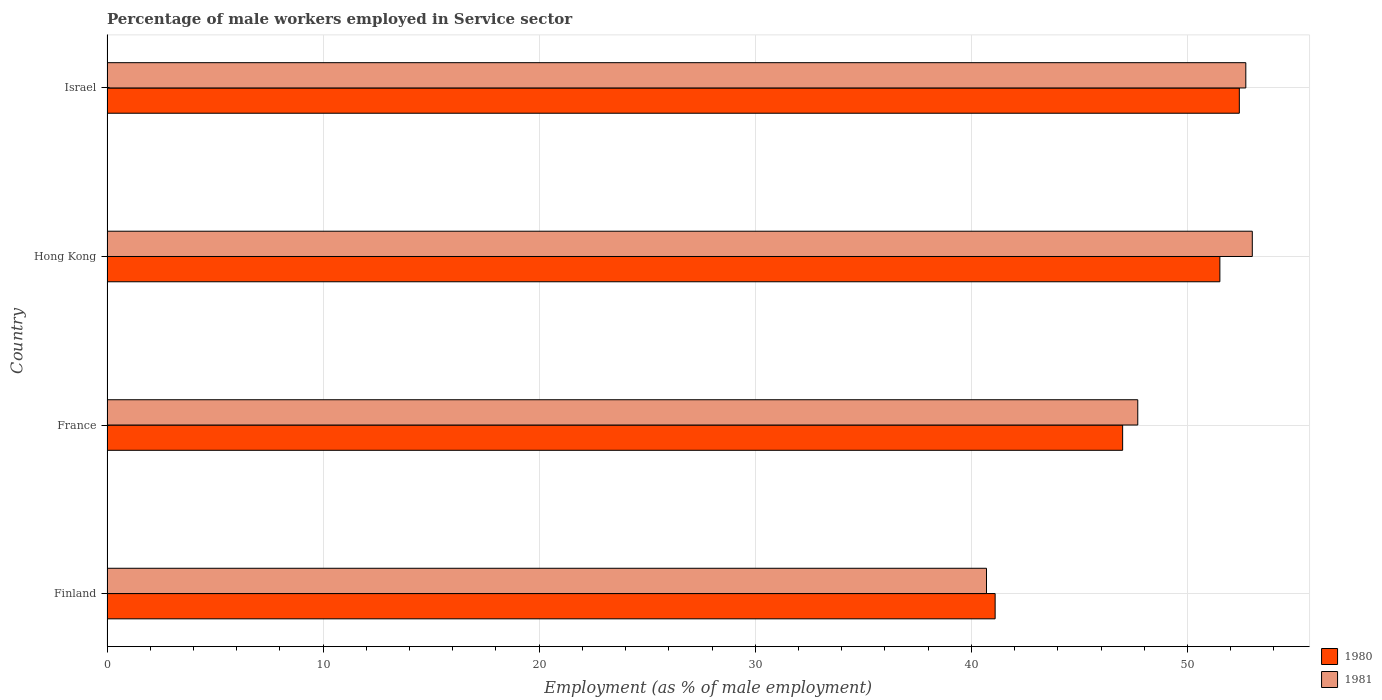How many different coloured bars are there?
Give a very brief answer. 2. How many groups of bars are there?
Provide a succinct answer. 4. Are the number of bars per tick equal to the number of legend labels?
Give a very brief answer. Yes. How many bars are there on the 1st tick from the top?
Provide a succinct answer. 2. How many bars are there on the 4th tick from the bottom?
Make the answer very short. 2. What is the label of the 3rd group of bars from the top?
Offer a very short reply. France. In how many cases, is the number of bars for a given country not equal to the number of legend labels?
Provide a succinct answer. 0. Across all countries, what is the maximum percentage of male workers employed in Service sector in 1981?
Your answer should be compact. 53. Across all countries, what is the minimum percentage of male workers employed in Service sector in 1980?
Your answer should be very brief. 41.1. In which country was the percentage of male workers employed in Service sector in 1981 maximum?
Keep it short and to the point. Hong Kong. What is the total percentage of male workers employed in Service sector in 1981 in the graph?
Keep it short and to the point. 194.1. What is the difference between the percentage of male workers employed in Service sector in 1980 in Finland and that in France?
Offer a very short reply. -5.9. What is the difference between the percentage of male workers employed in Service sector in 1980 in Hong Kong and the percentage of male workers employed in Service sector in 1981 in Israel?
Make the answer very short. -1.2. What is the average percentage of male workers employed in Service sector in 1981 per country?
Make the answer very short. 48.53. In how many countries, is the percentage of male workers employed in Service sector in 1981 greater than 46 %?
Your answer should be compact. 3. What is the ratio of the percentage of male workers employed in Service sector in 1981 in Finland to that in France?
Make the answer very short. 0.85. Is the difference between the percentage of male workers employed in Service sector in 1981 in France and Israel greater than the difference between the percentage of male workers employed in Service sector in 1980 in France and Israel?
Provide a succinct answer. Yes. What is the difference between the highest and the second highest percentage of male workers employed in Service sector in 1981?
Your answer should be compact. 0.3. What is the difference between the highest and the lowest percentage of male workers employed in Service sector in 1980?
Provide a succinct answer. 11.3. In how many countries, is the percentage of male workers employed in Service sector in 1980 greater than the average percentage of male workers employed in Service sector in 1980 taken over all countries?
Provide a short and direct response. 2. What does the 2nd bar from the top in Hong Kong represents?
Your answer should be very brief. 1980. How many countries are there in the graph?
Provide a succinct answer. 4. Does the graph contain any zero values?
Ensure brevity in your answer.  No. Does the graph contain grids?
Provide a short and direct response. Yes. What is the title of the graph?
Give a very brief answer. Percentage of male workers employed in Service sector. Does "1964" appear as one of the legend labels in the graph?
Offer a terse response. No. What is the label or title of the X-axis?
Provide a succinct answer. Employment (as % of male employment). What is the label or title of the Y-axis?
Your answer should be very brief. Country. What is the Employment (as % of male employment) of 1980 in Finland?
Provide a succinct answer. 41.1. What is the Employment (as % of male employment) of 1981 in Finland?
Keep it short and to the point. 40.7. What is the Employment (as % of male employment) in 1981 in France?
Your answer should be very brief. 47.7. What is the Employment (as % of male employment) in 1980 in Hong Kong?
Your response must be concise. 51.5. What is the Employment (as % of male employment) of 1981 in Hong Kong?
Your answer should be very brief. 53. What is the Employment (as % of male employment) of 1980 in Israel?
Offer a very short reply. 52.4. What is the Employment (as % of male employment) in 1981 in Israel?
Ensure brevity in your answer.  52.7. Across all countries, what is the maximum Employment (as % of male employment) in 1980?
Your response must be concise. 52.4. Across all countries, what is the maximum Employment (as % of male employment) in 1981?
Make the answer very short. 53. Across all countries, what is the minimum Employment (as % of male employment) in 1980?
Your response must be concise. 41.1. Across all countries, what is the minimum Employment (as % of male employment) of 1981?
Your answer should be compact. 40.7. What is the total Employment (as % of male employment) of 1980 in the graph?
Provide a succinct answer. 192. What is the total Employment (as % of male employment) in 1981 in the graph?
Offer a terse response. 194.1. What is the difference between the Employment (as % of male employment) of 1980 in Finland and that in France?
Your response must be concise. -5.9. What is the difference between the Employment (as % of male employment) of 1981 in Finland and that in France?
Your response must be concise. -7. What is the difference between the Employment (as % of male employment) in 1980 in Finland and that in Hong Kong?
Your response must be concise. -10.4. What is the difference between the Employment (as % of male employment) of 1981 in Finland and that in Hong Kong?
Offer a terse response. -12.3. What is the difference between the Employment (as % of male employment) of 1980 in Finland and that in Israel?
Your answer should be very brief. -11.3. What is the difference between the Employment (as % of male employment) of 1981 in Finland and that in Israel?
Your response must be concise. -12. What is the difference between the Employment (as % of male employment) of 1980 in France and that in Hong Kong?
Keep it short and to the point. -4.5. What is the difference between the Employment (as % of male employment) in 1981 in France and that in Hong Kong?
Provide a short and direct response. -5.3. What is the difference between the Employment (as % of male employment) of 1980 in France and that in Israel?
Your answer should be compact. -5.4. What is the difference between the Employment (as % of male employment) of 1980 in Finland and the Employment (as % of male employment) of 1981 in France?
Ensure brevity in your answer.  -6.6. What is the difference between the Employment (as % of male employment) of 1980 in Finland and the Employment (as % of male employment) of 1981 in Israel?
Provide a short and direct response. -11.6. What is the difference between the Employment (as % of male employment) of 1980 in France and the Employment (as % of male employment) of 1981 in Hong Kong?
Provide a short and direct response. -6. What is the average Employment (as % of male employment) of 1981 per country?
Ensure brevity in your answer.  48.52. What is the difference between the Employment (as % of male employment) in 1980 and Employment (as % of male employment) in 1981 in Finland?
Your answer should be very brief. 0.4. What is the difference between the Employment (as % of male employment) of 1980 and Employment (as % of male employment) of 1981 in France?
Keep it short and to the point. -0.7. What is the difference between the Employment (as % of male employment) of 1980 and Employment (as % of male employment) of 1981 in Hong Kong?
Make the answer very short. -1.5. What is the difference between the Employment (as % of male employment) of 1980 and Employment (as % of male employment) of 1981 in Israel?
Offer a terse response. -0.3. What is the ratio of the Employment (as % of male employment) of 1980 in Finland to that in France?
Make the answer very short. 0.87. What is the ratio of the Employment (as % of male employment) in 1981 in Finland to that in France?
Your response must be concise. 0.85. What is the ratio of the Employment (as % of male employment) of 1980 in Finland to that in Hong Kong?
Your answer should be very brief. 0.8. What is the ratio of the Employment (as % of male employment) in 1981 in Finland to that in Hong Kong?
Offer a terse response. 0.77. What is the ratio of the Employment (as % of male employment) in 1980 in Finland to that in Israel?
Your answer should be compact. 0.78. What is the ratio of the Employment (as % of male employment) in 1981 in Finland to that in Israel?
Provide a short and direct response. 0.77. What is the ratio of the Employment (as % of male employment) of 1980 in France to that in Hong Kong?
Give a very brief answer. 0.91. What is the ratio of the Employment (as % of male employment) of 1981 in France to that in Hong Kong?
Your answer should be compact. 0.9. What is the ratio of the Employment (as % of male employment) of 1980 in France to that in Israel?
Make the answer very short. 0.9. What is the ratio of the Employment (as % of male employment) in 1981 in France to that in Israel?
Ensure brevity in your answer.  0.91. What is the ratio of the Employment (as % of male employment) in 1980 in Hong Kong to that in Israel?
Your answer should be compact. 0.98. What is the ratio of the Employment (as % of male employment) of 1981 in Hong Kong to that in Israel?
Offer a very short reply. 1.01. What is the difference between the highest and the lowest Employment (as % of male employment) in 1980?
Ensure brevity in your answer.  11.3. 